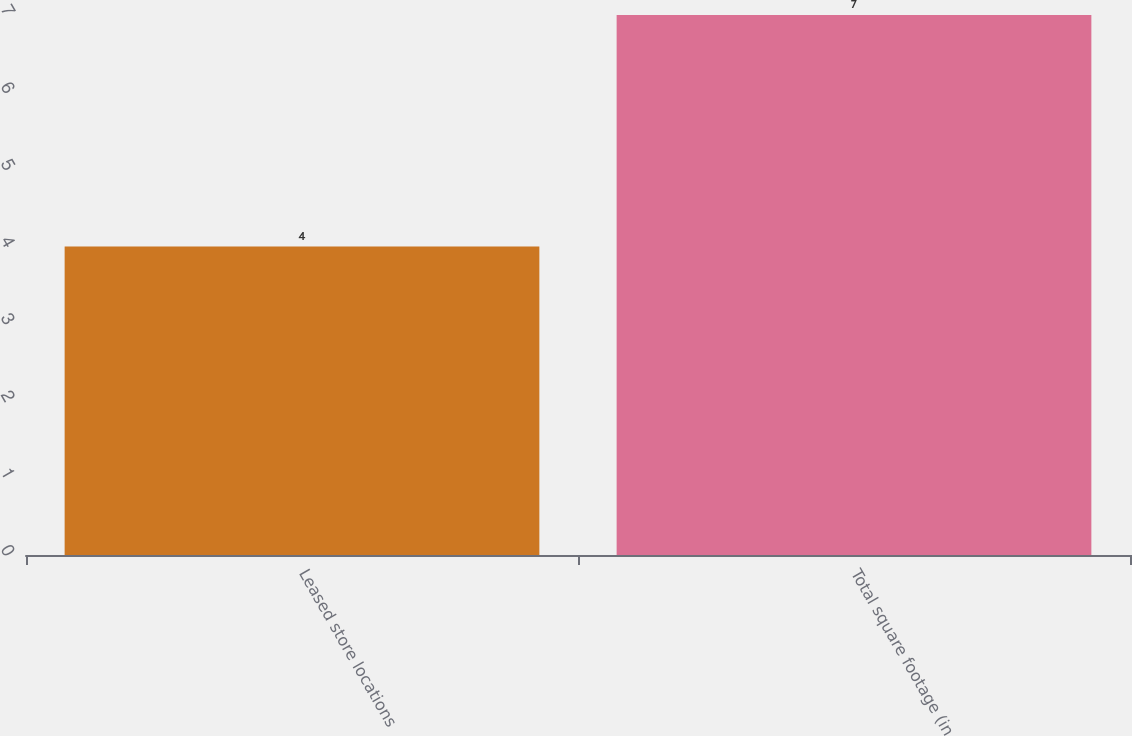Convert chart to OTSL. <chart><loc_0><loc_0><loc_500><loc_500><bar_chart><fcel>Leased store locations<fcel>Total square footage (in<nl><fcel>4<fcel>7<nl></chart> 